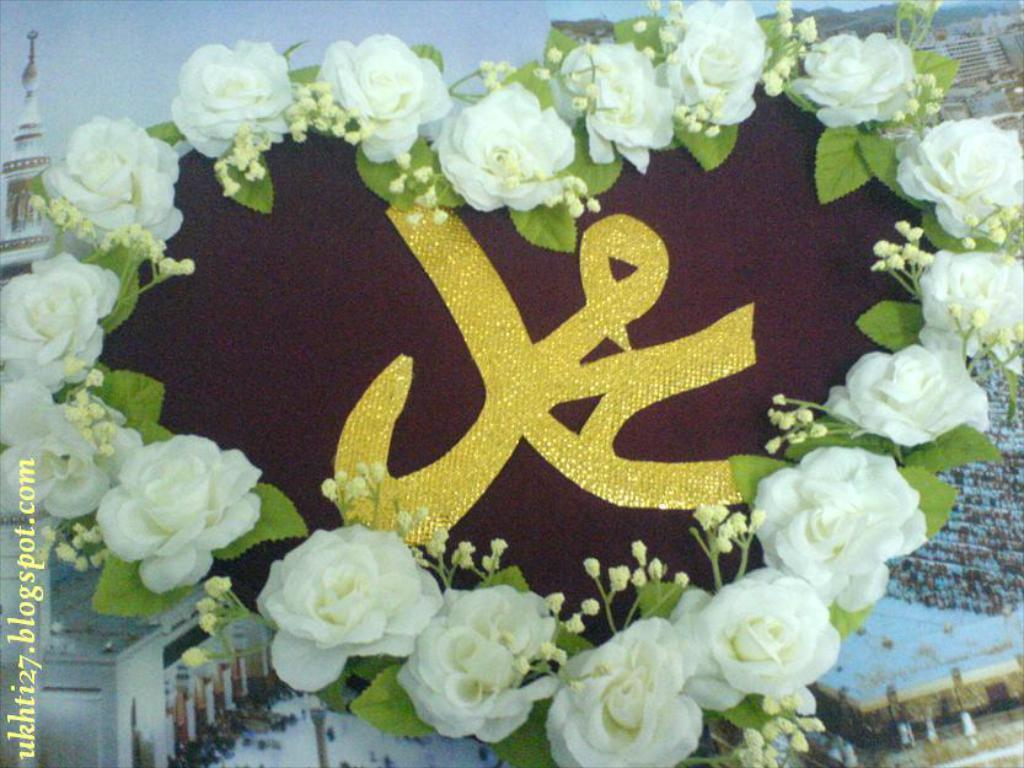What is the main subject in the foreground of the image? There is a heart-shaped object in the foreground of the image. What is surrounding the heart-shaped object? There are flowers around the heart-shaped object. What can be seen in the background of the image? There appears to be a poster in the background of the image. What type of curve can be seen on the box in the image? There is no box present in the image, so it is not possible to determine the type of curve on it. 